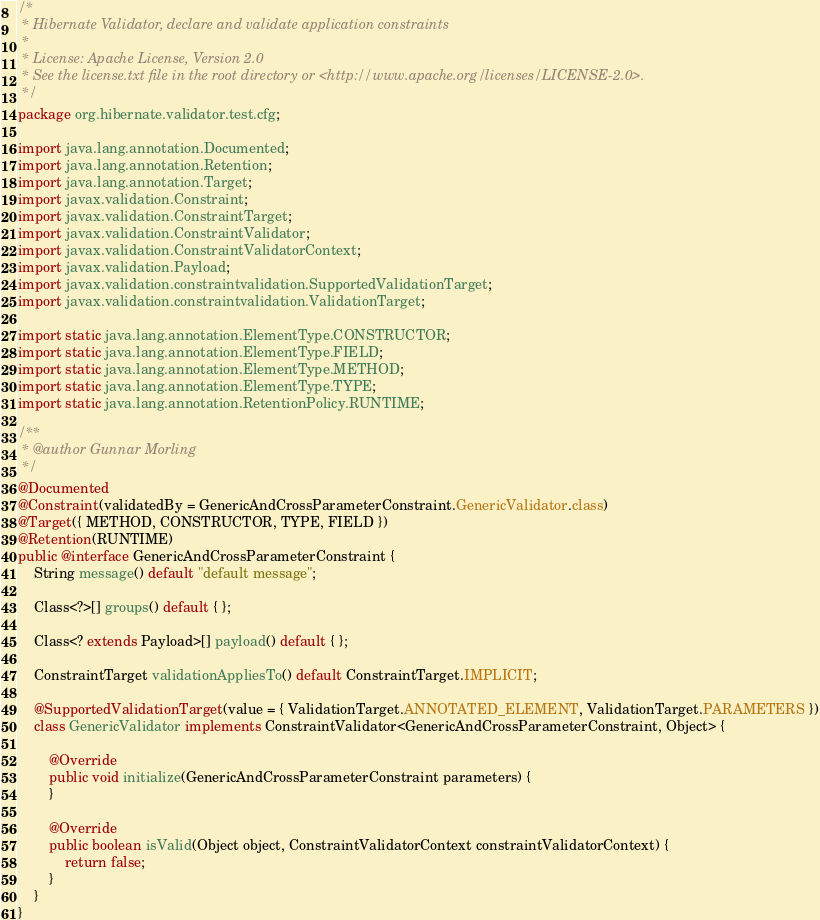Convert code to text. <code><loc_0><loc_0><loc_500><loc_500><_Java_>/*
 * Hibernate Validator, declare and validate application constraints
 *
 * License: Apache License, Version 2.0
 * See the license.txt file in the root directory or <http://www.apache.org/licenses/LICENSE-2.0>.
 */
package org.hibernate.validator.test.cfg;

import java.lang.annotation.Documented;
import java.lang.annotation.Retention;
import java.lang.annotation.Target;
import javax.validation.Constraint;
import javax.validation.ConstraintTarget;
import javax.validation.ConstraintValidator;
import javax.validation.ConstraintValidatorContext;
import javax.validation.Payload;
import javax.validation.constraintvalidation.SupportedValidationTarget;
import javax.validation.constraintvalidation.ValidationTarget;

import static java.lang.annotation.ElementType.CONSTRUCTOR;
import static java.lang.annotation.ElementType.FIELD;
import static java.lang.annotation.ElementType.METHOD;
import static java.lang.annotation.ElementType.TYPE;
import static java.lang.annotation.RetentionPolicy.RUNTIME;

/**
 * @author Gunnar Morling
 */
@Documented
@Constraint(validatedBy = GenericAndCrossParameterConstraint.GenericValidator.class)
@Target({ METHOD, CONSTRUCTOR, TYPE, FIELD })
@Retention(RUNTIME)
public @interface GenericAndCrossParameterConstraint {
	String message() default "default message";

	Class<?>[] groups() default { };

	Class<? extends Payload>[] payload() default { };

	ConstraintTarget validationAppliesTo() default ConstraintTarget.IMPLICIT;

	@SupportedValidationTarget(value = { ValidationTarget.ANNOTATED_ELEMENT, ValidationTarget.PARAMETERS })
	class GenericValidator implements ConstraintValidator<GenericAndCrossParameterConstraint, Object> {

		@Override
		public void initialize(GenericAndCrossParameterConstraint parameters) {
		}

		@Override
		public boolean isValid(Object object, ConstraintValidatorContext constraintValidatorContext) {
			return false;
		}
	}
}
</code> 